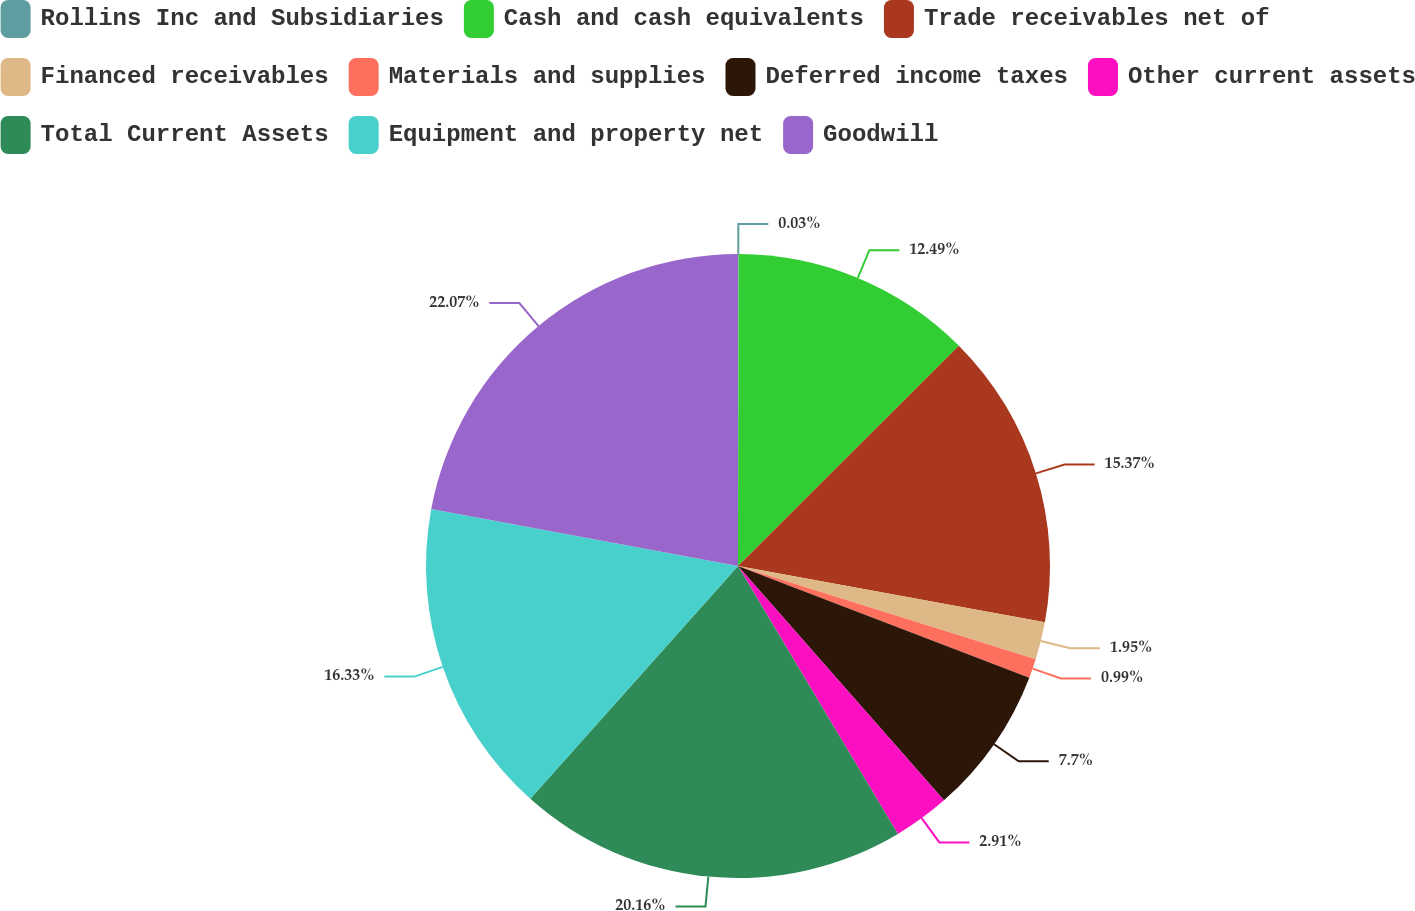Convert chart to OTSL. <chart><loc_0><loc_0><loc_500><loc_500><pie_chart><fcel>Rollins Inc and Subsidiaries<fcel>Cash and cash equivalents<fcel>Trade receivables net of<fcel>Financed receivables<fcel>Materials and supplies<fcel>Deferred income taxes<fcel>Other current assets<fcel>Total Current Assets<fcel>Equipment and property net<fcel>Goodwill<nl><fcel>0.03%<fcel>12.49%<fcel>15.37%<fcel>1.95%<fcel>0.99%<fcel>7.7%<fcel>2.91%<fcel>20.16%<fcel>16.33%<fcel>22.08%<nl></chart> 